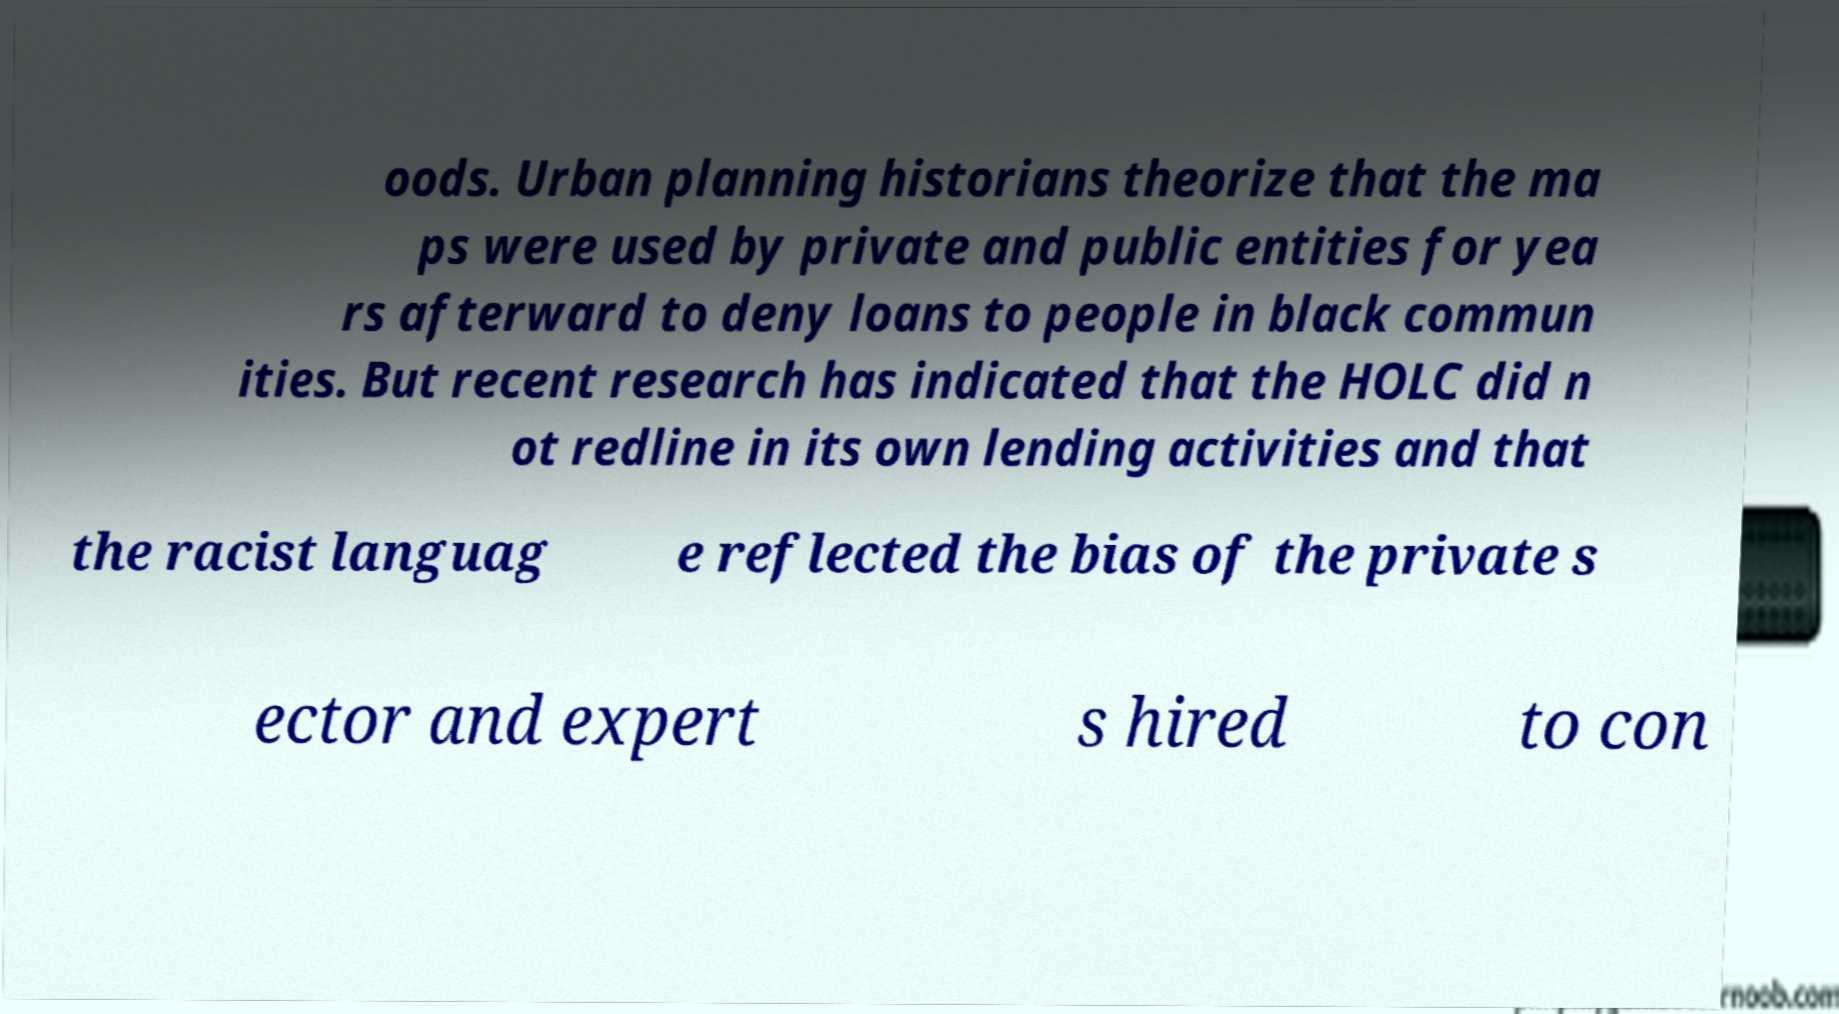What messages or text are displayed in this image? I need them in a readable, typed format. oods. Urban planning historians theorize that the ma ps were used by private and public entities for yea rs afterward to deny loans to people in black commun ities. But recent research has indicated that the HOLC did n ot redline in its own lending activities and that the racist languag e reflected the bias of the private s ector and expert s hired to con 